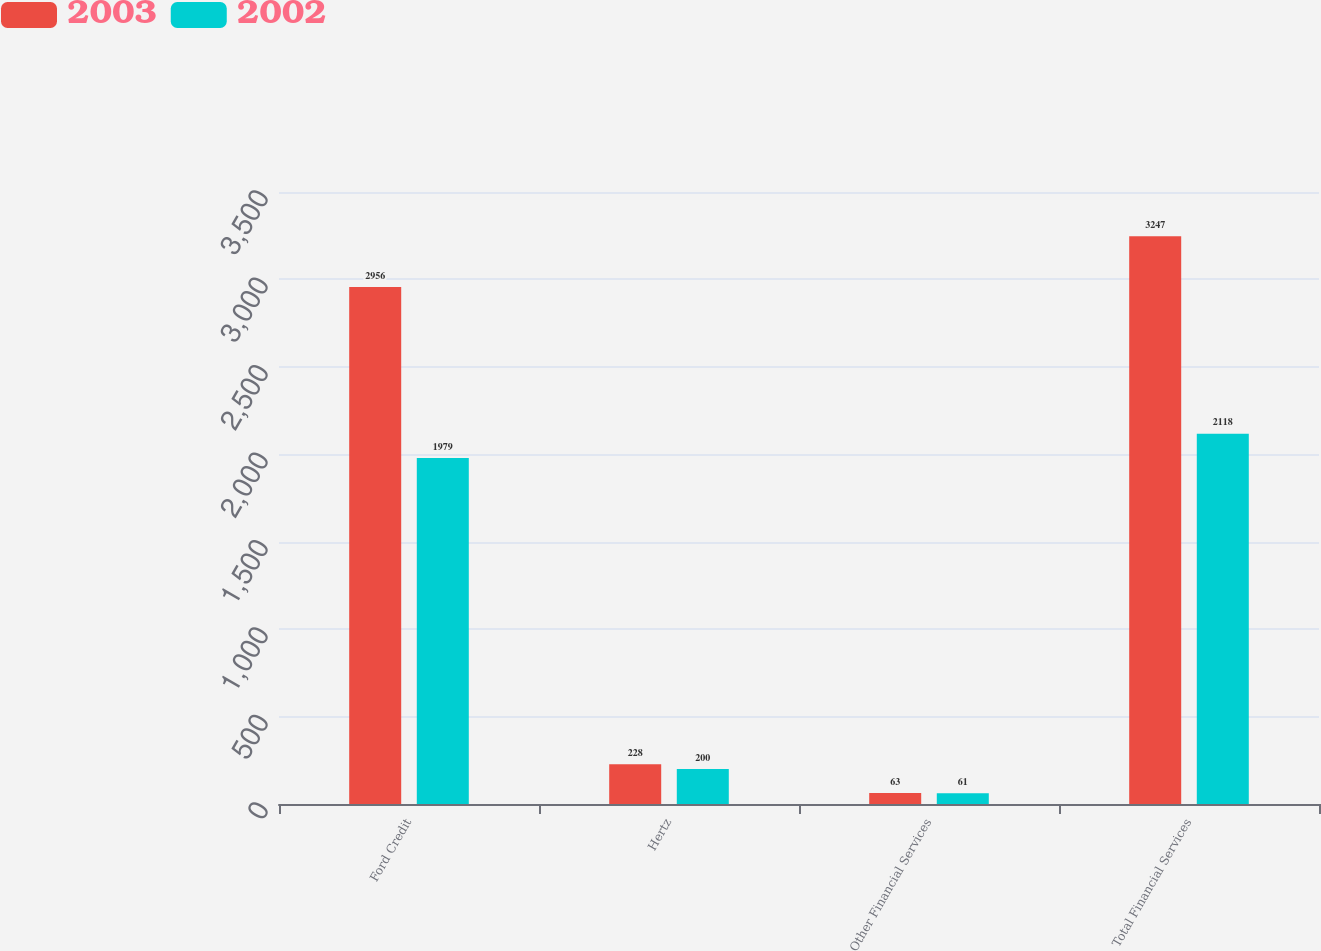<chart> <loc_0><loc_0><loc_500><loc_500><stacked_bar_chart><ecel><fcel>Ford Credit<fcel>Hertz<fcel>Other Financial Services<fcel>Total Financial Services<nl><fcel>2003<fcel>2956<fcel>228<fcel>63<fcel>3247<nl><fcel>2002<fcel>1979<fcel>200<fcel>61<fcel>2118<nl></chart> 